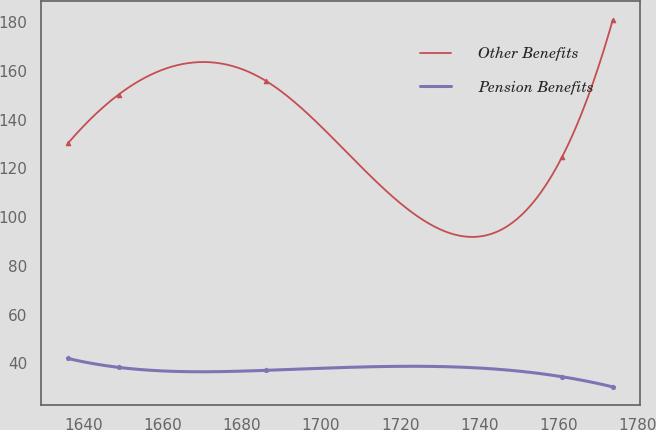<chart> <loc_0><loc_0><loc_500><loc_500><line_chart><ecel><fcel>Other Benefits<fcel>Pension Benefits<nl><fcel>1636.13<fcel>130.26<fcel>41.96<nl><fcel>1648.95<fcel>150.3<fcel>38.3<nl><fcel>1686.08<fcel>155.93<fcel>37.08<nl><fcel>1760.86<fcel>124.63<fcel>34.46<nl><fcel>1773.68<fcel>180.96<fcel>30.28<nl></chart> 